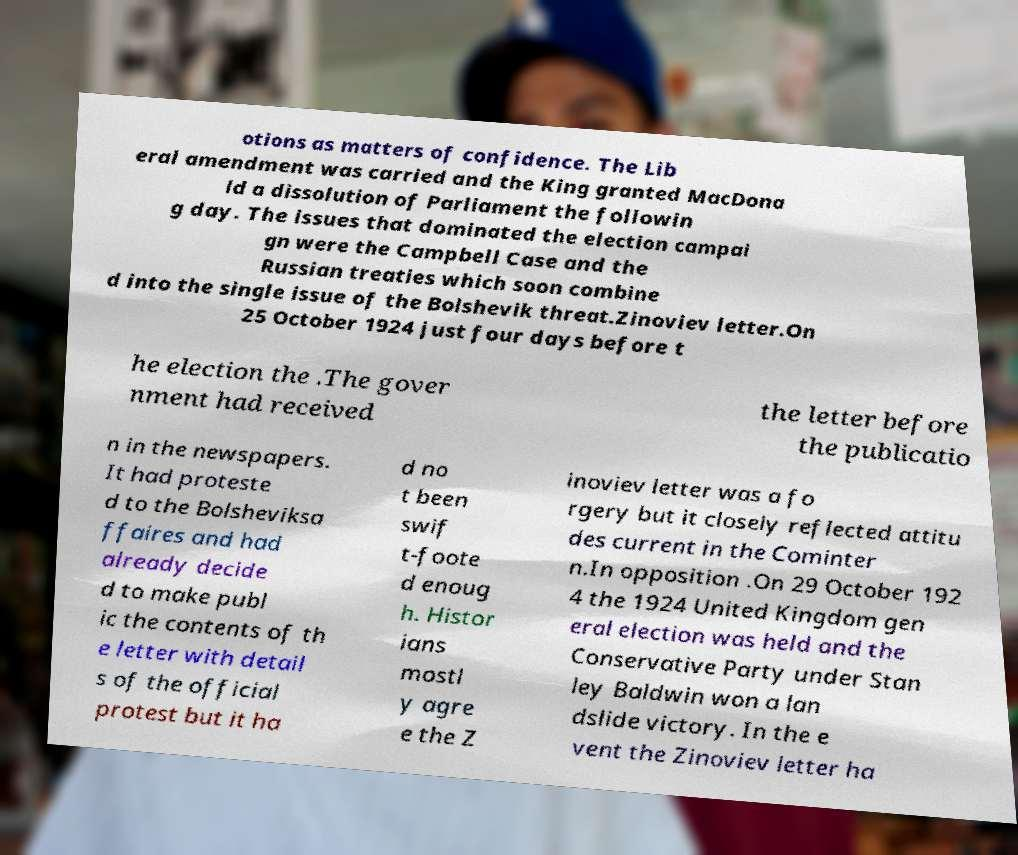Could you assist in decoding the text presented in this image and type it out clearly? otions as matters of confidence. The Lib eral amendment was carried and the King granted MacDona ld a dissolution of Parliament the followin g day. The issues that dominated the election campai gn were the Campbell Case and the Russian treaties which soon combine d into the single issue of the Bolshevik threat.Zinoviev letter.On 25 October 1924 just four days before t he election the .The gover nment had received the letter before the publicatio n in the newspapers. It had proteste d to the Bolsheviksa ffaires and had already decide d to make publ ic the contents of th e letter with detail s of the official protest but it ha d no t been swif t-foote d enoug h. Histor ians mostl y agre e the Z inoviev letter was a fo rgery but it closely reflected attitu des current in the Cominter n.In opposition .On 29 October 192 4 the 1924 United Kingdom gen eral election was held and the Conservative Party under Stan ley Baldwin won a lan dslide victory. In the e vent the Zinoviev letter ha 